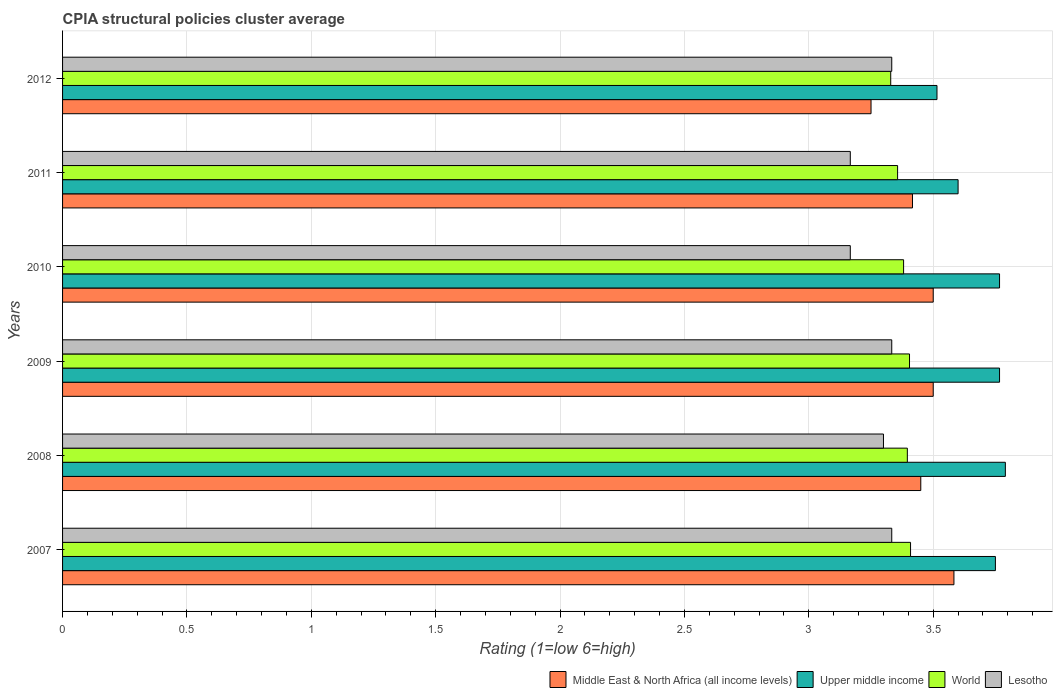Are the number of bars per tick equal to the number of legend labels?
Offer a terse response. Yes. Are the number of bars on each tick of the Y-axis equal?
Provide a short and direct response. Yes. How many bars are there on the 5th tick from the top?
Give a very brief answer. 4. What is the CPIA rating in Upper middle income in 2007?
Your response must be concise. 3.75. Across all years, what is the maximum CPIA rating in World?
Your answer should be compact. 3.41. Across all years, what is the minimum CPIA rating in Middle East & North Africa (all income levels)?
Keep it short and to the point. 3.25. What is the total CPIA rating in Lesotho in the graph?
Make the answer very short. 19.63. What is the difference between the CPIA rating in Middle East & North Africa (all income levels) in 2008 and that in 2012?
Provide a short and direct response. 0.2. What is the difference between the CPIA rating in Middle East & North Africa (all income levels) in 2009 and the CPIA rating in World in 2012?
Offer a very short reply. 0.17. What is the average CPIA rating in Lesotho per year?
Make the answer very short. 3.27. In the year 2011, what is the difference between the CPIA rating in Upper middle income and CPIA rating in World?
Provide a succinct answer. 0.24. In how many years, is the CPIA rating in Middle East & North Africa (all income levels) greater than 2.1 ?
Give a very brief answer. 6. What is the ratio of the CPIA rating in World in 2009 to that in 2012?
Your response must be concise. 1.02. What is the difference between the highest and the second highest CPIA rating in Upper middle income?
Give a very brief answer. 0.02. What is the difference between the highest and the lowest CPIA rating in World?
Provide a succinct answer. 0.08. In how many years, is the CPIA rating in World greater than the average CPIA rating in World taken over all years?
Your answer should be compact. 4. Is the sum of the CPIA rating in Middle East & North Africa (all income levels) in 2011 and 2012 greater than the maximum CPIA rating in World across all years?
Ensure brevity in your answer.  Yes. Is it the case that in every year, the sum of the CPIA rating in World and CPIA rating in Middle East & North Africa (all income levels) is greater than the sum of CPIA rating in Lesotho and CPIA rating in Upper middle income?
Provide a succinct answer. No. What does the 4th bar from the top in 2011 represents?
Your answer should be very brief. Middle East & North Africa (all income levels). What does the 4th bar from the bottom in 2012 represents?
Provide a succinct answer. Lesotho. Is it the case that in every year, the sum of the CPIA rating in World and CPIA rating in Upper middle income is greater than the CPIA rating in Middle East & North Africa (all income levels)?
Keep it short and to the point. Yes. How many bars are there?
Your answer should be very brief. 24. How many years are there in the graph?
Provide a short and direct response. 6. What is the difference between two consecutive major ticks on the X-axis?
Ensure brevity in your answer.  0.5. Are the values on the major ticks of X-axis written in scientific E-notation?
Your answer should be compact. No. Does the graph contain any zero values?
Offer a terse response. No. Does the graph contain grids?
Provide a short and direct response. Yes. How many legend labels are there?
Make the answer very short. 4. How are the legend labels stacked?
Provide a short and direct response. Horizontal. What is the title of the graph?
Offer a terse response. CPIA structural policies cluster average. What is the label or title of the X-axis?
Make the answer very short. Rating (1=low 6=high). What is the label or title of the Y-axis?
Your answer should be very brief. Years. What is the Rating (1=low 6=high) of Middle East & North Africa (all income levels) in 2007?
Offer a terse response. 3.58. What is the Rating (1=low 6=high) in Upper middle income in 2007?
Ensure brevity in your answer.  3.75. What is the Rating (1=low 6=high) in World in 2007?
Keep it short and to the point. 3.41. What is the Rating (1=low 6=high) of Lesotho in 2007?
Your answer should be very brief. 3.33. What is the Rating (1=low 6=high) of Middle East & North Africa (all income levels) in 2008?
Keep it short and to the point. 3.45. What is the Rating (1=low 6=high) in Upper middle income in 2008?
Provide a succinct answer. 3.79. What is the Rating (1=low 6=high) in World in 2008?
Offer a very short reply. 3.4. What is the Rating (1=low 6=high) of Lesotho in 2008?
Make the answer very short. 3.3. What is the Rating (1=low 6=high) in Upper middle income in 2009?
Provide a short and direct response. 3.77. What is the Rating (1=low 6=high) of World in 2009?
Your answer should be very brief. 3.4. What is the Rating (1=low 6=high) in Lesotho in 2009?
Give a very brief answer. 3.33. What is the Rating (1=low 6=high) in Middle East & North Africa (all income levels) in 2010?
Your response must be concise. 3.5. What is the Rating (1=low 6=high) of Upper middle income in 2010?
Offer a terse response. 3.77. What is the Rating (1=low 6=high) in World in 2010?
Your answer should be compact. 3.38. What is the Rating (1=low 6=high) in Lesotho in 2010?
Offer a very short reply. 3.17. What is the Rating (1=low 6=high) of Middle East & North Africa (all income levels) in 2011?
Your answer should be very brief. 3.42. What is the Rating (1=low 6=high) in Upper middle income in 2011?
Make the answer very short. 3.6. What is the Rating (1=low 6=high) in World in 2011?
Your answer should be very brief. 3.36. What is the Rating (1=low 6=high) in Lesotho in 2011?
Make the answer very short. 3.17. What is the Rating (1=low 6=high) in Upper middle income in 2012?
Your answer should be compact. 3.52. What is the Rating (1=low 6=high) in World in 2012?
Make the answer very short. 3.33. What is the Rating (1=low 6=high) in Lesotho in 2012?
Keep it short and to the point. 3.33. Across all years, what is the maximum Rating (1=low 6=high) of Middle East & North Africa (all income levels)?
Give a very brief answer. 3.58. Across all years, what is the maximum Rating (1=low 6=high) of Upper middle income?
Keep it short and to the point. 3.79. Across all years, what is the maximum Rating (1=low 6=high) of World?
Ensure brevity in your answer.  3.41. Across all years, what is the maximum Rating (1=low 6=high) of Lesotho?
Provide a succinct answer. 3.33. Across all years, what is the minimum Rating (1=low 6=high) of Middle East & North Africa (all income levels)?
Provide a short and direct response. 3.25. Across all years, what is the minimum Rating (1=low 6=high) of Upper middle income?
Offer a very short reply. 3.52. Across all years, what is the minimum Rating (1=low 6=high) in World?
Make the answer very short. 3.33. Across all years, what is the minimum Rating (1=low 6=high) in Lesotho?
Offer a terse response. 3.17. What is the total Rating (1=low 6=high) of Middle East & North Africa (all income levels) in the graph?
Your response must be concise. 20.7. What is the total Rating (1=low 6=high) of Upper middle income in the graph?
Provide a short and direct response. 22.19. What is the total Rating (1=low 6=high) in World in the graph?
Keep it short and to the point. 20.28. What is the total Rating (1=low 6=high) in Lesotho in the graph?
Your answer should be compact. 19.63. What is the difference between the Rating (1=low 6=high) in Middle East & North Africa (all income levels) in 2007 and that in 2008?
Offer a terse response. 0.13. What is the difference between the Rating (1=low 6=high) in Upper middle income in 2007 and that in 2008?
Make the answer very short. -0.04. What is the difference between the Rating (1=low 6=high) in World in 2007 and that in 2008?
Offer a very short reply. 0.01. What is the difference between the Rating (1=low 6=high) in Lesotho in 2007 and that in 2008?
Your response must be concise. 0.03. What is the difference between the Rating (1=low 6=high) in Middle East & North Africa (all income levels) in 2007 and that in 2009?
Make the answer very short. 0.08. What is the difference between the Rating (1=low 6=high) of Upper middle income in 2007 and that in 2009?
Ensure brevity in your answer.  -0.02. What is the difference between the Rating (1=low 6=high) of World in 2007 and that in 2009?
Your response must be concise. 0. What is the difference between the Rating (1=low 6=high) in Middle East & North Africa (all income levels) in 2007 and that in 2010?
Ensure brevity in your answer.  0.08. What is the difference between the Rating (1=low 6=high) of Upper middle income in 2007 and that in 2010?
Provide a short and direct response. -0.02. What is the difference between the Rating (1=low 6=high) in World in 2007 and that in 2010?
Provide a short and direct response. 0.03. What is the difference between the Rating (1=low 6=high) in Lesotho in 2007 and that in 2010?
Offer a very short reply. 0.17. What is the difference between the Rating (1=low 6=high) of Upper middle income in 2007 and that in 2011?
Ensure brevity in your answer.  0.15. What is the difference between the Rating (1=low 6=high) of World in 2007 and that in 2011?
Your answer should be compact. 0.05. What is the difference between the Rating (1=low 6=high) of Upper middle income in 2007 and that in 2012?
Make the answer very short. 0.23. What is the difference between the Rating (1=low 6=high) in World in 2007 and that in 2012?
Make the answer very short. 0.08. What is the difference between the Rating (1=low 6=high) of Upper middle income in 2008 and that in 2009?
Your response must be concise. 0.02. What is the difference between the Rating (1=low 6=high) of World in 2008 and that in 2009?
Give a very brief answer. -0.01. What is the difference between the Rating (1=low 6=high) of Lesotho in 2008 and that in 2009?
Offer a terse response. -0.03. What is the difference between the Rating (1=low 6=high) in Middle East & North Africa (all income levels) in 2008 and that in 2010?
Give a very brief answer. -0.05. What is the difference between the Rating (1=low 6=high) in Upper middle income in 2008 and that in 2010?
Make the answer very short. 0.02. What is the difference between the Rating (1=low 6=high) of World in 2008 and that in 2010?
Keep it short and to the point. 0.01. What is the difference between the Rating (1=low 6=high) in Lesotho in 2008 and that in 2010?
Your response must be concise. 0.13. What is the difference between the Rating (1=low 6=high) in Middle East & North Africa (all income levels) in 2008 and that in 2011?
Your answer should be compact. 0.03. What is the difference between the Rating (1=low 6=high) of Upper middle income in 2008 and that in 2011?
Provide a succinct answer. 0.19. What is the difference between the Rating (1=low 6=high) of World in 2008 and that in 2011?
Keep it short and to the point. 0.04. What is the difference between the Rating (1=low 6=high) of Lesotho in 2008 and that in 2011?
Provide a succinct answer. 0.13. What is the difference between the Rating (1=low 6=high) in Middle East & North Africa (all income levels) in 2008 and that in 2012?
Provide a succinct answer. 0.2. What is the difference between the Rating (1=low 6=high) in Upper middle income in 2008 and that in 2012?
Keep it short and to the point. 0.27. What is the difference between the Rating (1=low 6=high) in World in 2008 and that in 2012?
Make the answer very short. 0.07. What is the difference between the Rating (1=low 6=high) of Lesotho in 2008 and that in 2012?
Ensure brevity in your answer.  -0.03. What is the difference between the Rating (1=low 6=high) of Middle East & North Africa (all income levels) in 2009 and that in 2010?
Your answer should be compact. 0. What is the difference between the Rating (1=low 6=high) of World in 2009 and that in 2010?
Keep it short and to the point. 0.02. What is the difference between the Rating (1=low 6=high) of Lesotho in 2009 and that in 2010?
Your answer should be compact. 0.17. What is the difference between the Rating (1=low 6=high) of Middle East & North Africa (all income levels) in 2009 and that in 2011?
Your response must be concise. 0.08. What is the difference between the Rating (1=low 6=high) in Upper middle income in 2009 and that in 2011?
Give a very brief answer. 0.17. What is the difference between the Rating (1=low 6=high) in World in 2009 and that in 2011?
Provide a short and direct response. 0.05. What is the difference between the Rating (1=low 6=high) in Lesotho in 2009 and that in 2011?
Keep it short and to the point. 0.17. What is the difference between the Rating (1=low 6=high) of Middle East & North Africa (all income levels) in 2009 and that in 2012?
Your response must be concise. 0.25. What is the difference between the Rating (1=low 6=high) in Upper middle income in 2009 and that in 2012?
Offer a very short reply. 0.25. What is the difference between the Rating (1=low 6=high) of World in 2009 and that in 2012?
Your answer should be very brief. 0.08. What is the difference between the Rating (1=low 6=high) in Lesotho in 2009 and that in 2012?
Provide a short and direct response. 0. What is the difference between the Rating (1=low 6=high) of Middle East & North Africa (all income levels) in 2010 and that in 2011?
Ensure brevity in your answer.  0.08. What is the difference between the Rating (1=low 6=high) of World in 2010 and that in 2011?
Provide a succinct answer. 0.02. What is the difference between the Rating (1=low 6=high) in Lesotho in 2010 and that in 2011?
Your answer should be very brief. 0. What is the difference between the Rating (1=low 6=high) of Middle East & North Africa (all income levels) in 2010 and that in 2012?
Your response must be concise. 0.25. What is the difference between the Rating (1=low 6=high) of Upper middle income in 2010 and that in 2012?
Provide a short and direct response. 0.25. What is the difference between the Rating (1=low 6=high) of World in 2010 and that in 2012?
Ensure brevity in your answer.  0.05. What is the difference between the Rating (1=low 6=high) of Lesotho in 2010 and that in 2012?
Offer a very short reply. -0.17. What is the difference between the Rating (1=low 6=high) in Middle East & North Africa (all income levels) in 2011 and that in 2012?
Provide a short and direct response. 0.17. What is the difference between the Rating (1=low 6=high) in Upper middle income in 2011 and that in 2012?
Your answer should be very brief. 0.08. What is the difference between the Rating (1=low 6=high) of World in 2011 and that in 2012?
Keep it short and to the point. 0.03. What is the difference between the Rating (1=low 6=high) of Lesotho in 2011 and that in 2012?
Your response must be concise. -0.17. What is the difference between the Rating (1=low 6=high) in Middle East & North Africa (all income levels) in 2007 and the Rating (1=low 6=high) in Upper middle income in 2008?
Make the answer very short. -0.21. What is the difference between the Rating (1=low 6=high) of Middle East & North Africa (all income levels) in 2007 and the Rating (1=low 6=high) of World in 2008?
Keep it short and to the point. 0.19. What is the difference between the Rating (1=low 6=high) in Middle East & North Africa (all income levels) in 2007 and the Rating (1=low 6=high) in Lesotho in 2008?
Your answer should be compact. 0.28. What is the difference between the Rating (1=low 6=high) of Upper middle income in 2007 and the Rating (1=low 6=high) of World in 2008?
Your answer should be compact. 0.35. What is the difference between the Rating (1=low 6=high) of Upper middle income in 2007 and the Rating (1=low 6=high) of Lesotho in 2008?
Offer a terse response. 0.45. What is the difference between the Rating (1=low 6=high) of World in 2007 and the Rating (1=low 6=high) of Lesotho in 2008?
Your answer should be very brief. 0.11. What is the difference between the Rating (1=low 6=high) of Middle East & North Africa (all income levels) in 2007 and the Rating (1=low 6=high) of Upper middle income in 2009?
Ensure brevity in your answer.  -0.18. What is the difference between the Rating (1=low 6=high) of Middle East & North Africa (all income levels) in 2007 and the Rating (1=low 6=high) of World in 2009?
Keep it short and to the point. 0.18. What is the difference between the Rating (1=low 6=high) of Upper middle income in 2007 and the Rating (1=low 6=high) of World in 2009?
Ensure brevity in your answer.  0.35. What is the difference between the Rating (1=low 6=high) of Upper middle income in 2007 and the Rating (1=low 6=high) of Lesotho in 2009?
Your answer should be compact. 0.42. What is the difference between the Rating (1=low 6=high) in World in 2007 and the Rating (1=low 6=high) in Lesotho in 2009?
Provide a succinct answer. 0.08. What is the difference between the Rating (1=low 6=high) in Middle East & North Africa (all income levels) in 2007 and the Rating (1=low 6=high) in Upper middle income in 2010?
Provide a short and direct response. -0.18. What is the difference between the Rating (1=low 6=high) in Middle East & North Africa (all income levels) in 2007 and the Rating (1=low 6=high) in World in 2010?
Provide a short and direct response. 0.2. What is the difference between the Rating (1=low 6=high) in Middle East & North Africa (all income levels) in 2007 and the Rating (1=low 6=high) in Lesotho in 2010?
Provide a succinct answer. 0.42. What is the difference between the Rating (1=low 6=high) of Upper middle income in 2007 and the Rating (1=low 6=high) of World in 2010?
Provide a short and direct response. 0.37. What is the difference between the Rating (1=low 6=high) in Upper middle income in 2007 and the Rating (1=low 6=high) in Lesotho in 2010?
Your answer should be compact. 0.58. What is the difference between the Rating (1=low 6=high) in World in 2007 and the Rating (1=low 6=high) in Lesotho in 2010?
Provide a short and direct response. 0.24. What is the difference between the Rating (1=low 6=high) of Middle East & North Africa (all income levels) in 2007 and the Rating (1=low 6=high) of Upper middle income in 2011?
Your response must be concise. -0.02. What is the difference between the Rating (1=low 6=high) in Middle East & North Africa (all income levels) in 2007 and the Rating (1=low 6=high) in World in 2011?
Your answer should be compact. 0.23. What is the difference between the Rating (1=low 6=high) in Middle East & North Africa (all income levels) in 2007 and the Rating (1=low 6=high) in Lesotho in 2011?
Your answer should be very brief. 0.42. What is the difference between the Rating (1=low 6=high) of Upper middle income in 2007 and the Rating (1=low 6=high) of World in 2011?
Keep it short and to the point. 0.39. What is the difference between the Rating (1=low 6=high) of Upper middle income in 2007 and the Rating (1=low 6=high) of Lesotho in 2011?
Ensure brevity in your answer.  0.58. What is the difference between the Rating (1=low 6=high) in World in 2007 and the Rating (1=low 6=high) in Lesotho in 2011?
Your response must be concise. 0.24. What is the difference between the Rating (1=low 6=high) of Middle East & North Africa (all income levels) in 2007 and the Rating (1=low 6=high) of Upper middle income in 2012?
Keep it short and to the point. 0.07. What is the difference between the Rating (1=low 6=high) of Middle East & North Africa (all income levels) in 2007 and the Rating (1=low 6=high) of World in 2012?
Your response must be concise. 0.25. What is the difference between the Rating (1=low 6=high) in Middle East & North Africa (all income levels) in 2007 and the Rating (1=low 6=high) in Lesotho in 2012?
Make the answer very short. 0.25. What is the difference between the Rating (1=low 6=high) of Upper middle income in 2007 and the Rating (1=low 6=high) of World in 2012?
Make the answer very short. 0.42. What is the difference between the Rating (1=low 6=high) in Upper middle income in 2007 and the Rating (1=low 6=high) in Lesotho in 2012?
Offer a terse response. 0.42. What is the difference between the Rating (1=low 6=high) in World in 2007 and the Rating (1=low 6=high) in Lesotho in 2012?
Your response must be concise. 0.08. What is the difference between the Rating (1=low 6=high) in Middle East & North Africa (all income levels) in 2008 and the Rating (1=low 6=high) in Upper middle income in 2009?
Offer a very short reply. -0.32. What is the difference between the Rating (1=low 6=high) in Middle East & North Africa (all income levels) in 2008 and the Rating (1=low 6=high) in World in 2009?
Your response must be concise. 0.05. What is the difference between the Rating (1=low 6=high) in Middle East & North Africa (all income levels) in 2008 and the Rating (1=low 6=high) in Lesotho in 2009?
Offer a terse response. 0.12. What is the difference between the Rating (1=low 6=high) of Upper middle income in 2008 and the Rating (1=low 6=high) of World in 2009?
Your answer should be compact. 0.39. What is the difference between the Rating (1=low 6=high) in Upper middle income in 2008 and the Rating (1=low 6=high) in Lesotho in 2009?
Give a very brief answer. 0.46. What is the difference between the Rating (1=low 6=high) in World in 2008 and the Rating (1=low 6=high) in Lesotho in 2009?
Your response must be concise. 0.06. What is the difference between the Rating (1=low 6=high) in Middle East & North Africa (all income levels) in 2008 and the Rating (1=low 6=high) in Upper middle income in 2010?
Offer a very short reply. -0.32. What is the difference between the Rating (1=low 6=high) of Middle East & North Africa (all income levels) in 2008 and the Rating (1=low 6=high) of World in 2010?
Offer a very short reply. 0.07. What is the difference between the Rating (1=low 6=high) of Middle East & North Africa (all income levels) in 2008 and the Rating (1=low 6=high) of Lesotho in 2010?
Make the answer very short. 0.28. What is the difference between the Rating (1=low 6=high) in Upper middle income in 2008 and the Rating (1=low 6=high) in World in 2010?
Your answer should be compact. 0.41. What is the difference between the Rating (1=low 6=high) of Upper middle income in 2008 and the Rating (1=low 6=high) of Lesotho in 2010?
Provide a short and direct response. 0.62. What is the difference between the Rating (1=low 6=high) of World in 2008 and the Rating (1=low 6=high) of Lesotho in 2010?
Your answer should be compact. 0.23. What is the difference between the Rating (1=low 6=high) of Middle East & North Africa (all income levels) in 2008 and the Rating (1=low 6=high) of Upper middle income in 2011?
Keep it short and to the point. -0.15. What is the difference between the Rating (1=low 6=high) in Middle East & North Africa (all income levels) in 2008 and the Rating (1=low 6=high) in World in 2011?
Your answer should be compact. 0.09. What is the difference between the Rating (1=low 6=high) in Middle East & North Africa (all income levels) in 2008 and the Rating (1=low 6=high) in Lesotho in 2011?
Your response must be concise. 0.28. What is the difference between the Rating (1=low 6=high) in Upper middle income in 2008 and the Rating (1=low 6=high) in World in 2011?
Offer a very short reply. 0.43. What is the difference between the Rating (1=low 6=high) in Upper middle income in 2008 and the Rating (1=low 6=high) in Lesotho in 2011?
Keep it short and to the point. 0.62. What is the difference between the Rating (1=low 6=high) of World in 2008 and the Rating (1=low 6=high) of Lesotho in 2011?
Keep it short and to the point. 0.23. What is the difference between the Rating (1=low 6=high) in Middle East & North Africa (all income levels) in 2008 and the Rating (1=low 6=high) in Upper middle income in 2012?
Offer a very short reply. -0.07. What is the difference between the Rating (1=low 6=high) of Middle East & North Africa (all income levels) in 2008 and the Rating (1=low 6=high) of World in 2012?
Ensure brevity in your answer.  0.12. What is the difference between the Rating (1=low 6=high) in Middle East & North Africa (all income levels) in 2008 and the Rating (1=low 6=high) in Lesotho in 2012?
Ensure brevity in your answer.  0.12. What is the difference between the Rating (1=low 6=high) in Upper middle income in 2008 and the Rating (1=low 6=high) in World in 2012?
Offer a terse response. 0.46. What is the difference between the Rating (1=low 6=high) of Upper middle income in 2008 and the Rating (1=low 6=high) of Lesotho in 2012?
Provide a short and direct response. 0.46. What is the difference between the Rating (1=low 6=high) of World in 2008 and the Rating (1=low 6=high) of Lesotho in 2012?
Your answer should be very brief. 0.06. What is the difference between the Rating (1=low 6=high) in Middle East & North Africa (all income levels) in 2009 and the Rating (1=low 6=high) in Upper middle income in 2010?
Make the answer very short. -0.27. What is the difference between the Rating (1=low 6=high) of Middle East & North Africa (all income levels) in 2009 and the Rating (1=low 6=high) of World in 2010?
Keep it short and to the point. 0.12. What is the difference between the Rating (1=low 6=high) in Upper middle income in 2009 and the Rating (1=low 6=high) in World in 2010?
Make the answer very short. 0.39. What is the difference between the Rating (1=low 6=high) in World in 2009 and the Rating (1=low 6=high) in Lesotho in 2010?
Ensure brevity in your answer.  0.24. What is the difference between the Rating (1=low 6=high) of Middle East & North Africa (all income levels) in 2009 and the Rating (1=low 6=high) of Upper middle income in 2011?
Ensure brevity in your answer.  -0.1. What is the difference between the Rating (1=low 6=high) in Middle East & North Africa (all income levels) in 2009 and the Rating (1=low 6=high) in World in 2011?
Give a very brief answer. 0.14. What is the difference between the Rating (1=low 6=high) of Upper middle income in 2009 and the Rating (1=low 6=high) of World in 2011?
Ensure brevity in your answer.  0.41. What is the difference between the Rating (1=low 6=high) in Upper middle income in 2009 and the Rating (1=low 6=high) in Lesotho in 2011?
Your response must be concise. 0.6. What is the difference between the Rating (1=low 6=high) in World in 2009 and the Rating (1=low 6=high) in Lesotho in 2011?
Offer a very short reply. 0.24. What is the difference between the Rating (1=low 6=high) of Middle East & North Africa (all income levels) in 2009 and the Rating (1=low 6=high) of Upper middle income in 2012?
Your response must be concise. -0.02. What is the difference between the Rating (1=low 6=high) in Middle East & North Africa (all income levels) in 2009 and the Rating (1=low 6=high) in World in 2012?
Give a very brief answer. 0.17. What is the difference between the Rating (1=low 6=high) in Middle East & North Africa (all income levels) in 2009 and the Rating (1=low 6=high) in Lesotho in 2012?
Keep it short and to the point. 0.17. What is the difference between the Rating (1=low 6=high) in Upper middle income in 2009 and the Rating (1=low 6=high) in World in 2012?
Provide a succinct answer. 0.44. What is the difference between the Rating (1=low 6=high) of Upper middle income in 2009 and the Rating (1=low 6=high) of Lesotho in 2012?
Your answer should be compact. 0.43. What is the difference between the Rating (1=low 6=high) in World in 2009 and the Rating (1=low 6=high) in Lesotho in 2012?
Your answer should be compact. 0.07. What is the difference between the Rating (1=low 6=high) of Middle East & North Africa (all income levels) in 2010 and the Rating (1=low 6=high) of Upper middle income in 2011?
Provide a succinct answer. -0.1. What is the difference between the Rating (1=low 6=high) of Middle East & North Africa (all income levels) in 2010 and the Rating (1=low 6=high) of World in 2011?
Your response must be concise. 0.14. What is the difference between the Rating (1=low 6=high) in Upper middle income in 2010 and the Rating (1=low 6=high) in World in 2011?
Offer a terse response. 0.41. What is the difference between the Rating (1=low 6=high) of Upper middle income in 2010 and the Rating (1=low 6=high) of Lesotho in 2011?
Offer a very short reply. 0.6. What is the difference between the Rating (1=low 6=high) of World in 2010 and the Rating (1=low 6=high) of Lesotho in 2011?
Give a very brief answer. 0.21. What is the difference between the Rating (1=low 6=high) in Middle East & North Africa (all income levels) in 2010 and the Rating (1=low 6=high) in Upper middle income in 2012?
Keep it short and to the point. -0.02. What is the difference between the Rating (1=low 6=high) of Middle East & North Africa (all income levels) in 2010 and the Rating (1=low 6=high) of World in 2012?
Your answer should be compact. 0.17. What is the difference between the Rating (1=low 6=high) of Upper middle income in 2010 and the Rating (1=low 6=high) of World in 2012?
Offer a terse response. 0.44. What is the difference between the Rating (1=low 6=high) of Upper middle income in 2010 and the Rating (1=low 6=high) of Lesotho in 2012?
Provide a succinct answer. 0.43. What is the difference between the Rating (1=low 6=high) in World in 2010 and the Rating (1=low 6=high) in Lesotho in 2012?
Offer a very short reply. 0.05. What is the difference between the Rating (1=low 6=high) of Middle East & North Africa (all income levels) in 2011 and the Rating (1=low 6=high) of Upper middle income in 2012?
Make the answer very short. -0.1. What is the difference between the Rating (1=low 6=high) of Middle East & North Africa (all income levels) in 2011 and the Rating (1=low 6=high) of World in 2012?
Offer a terse response. 0.09. What is the difference between the Rating (1=low 6=high) of Middle East & North Africa (all income levels) in 2011 and the Rating (1=low 6=high) of Lesotho in 2012?
Ensure brevity in your answer.  0.08. What is the difference between the Rating (1=low 6=high) of Upper middle income in 2011 and the Rating (1=low 6=high) of World in 2012?
Your response must be concise. 0.27. What is the difference between the Rating (1=low 6=high) of Upper middle income in 2011 and the Rating (1=low 6=high) of Lesotho in 2012?
Ensure brevity in your answer.  0.27. What is the difference between the Rating (1=low 6=high) of World in 2011 and the Rating (1=low 6=high) of Lesotho in 2012?
Offer a very short reply. 0.02. What is the average Rating (1=low 6=high) of Middle East & North Africa (all income levels) per year?
Keep it short and to the point. 3.45. What is the average Rating (1=low 6=high) in Upper middle income per year?
Ensure brevity in your answer.  3.7. What is the average Rating (1=low 6=high) in World per year?
Provide a short and direct response. 3.38. What is the average Rating (1=low 6=high) in Lesotho per year?
Ensure brevity in your answer.  3.27. In the year 2007, what is the difference between the Rating (1=low 6=high) of Middle East & North Africa (all income levels) and Rating (1=low 6=high) of Upper middle income?
Offer a terse response. -0.17. In the year 2007, what is the difference between the Rating (1=low 6=high) of Middle East & North Africa (all income levels) and Rating (1=low 6=high) of World?
Ensure brevity in your answer.  0.17. In the year 2007, what is the difference between the Rating (1=low 6=high) of Upper middle income and Rating (1=low 6=high) of World?
Keep it short and to the point. 0.34. In the year 2007, what is the difference between the Rating (1=low 6=high) of Upper middle income and Rating (1=low 6=high) of Lesotho?
Ensure brevity in your answer.  0.42. In the year 2007, what is the difference between the Rating (1=low 6=high) of World and Rating (1=low 6=high) of Lesotho?
Your answer should be very brief. 0.08. In the year 2008, what is the difference between the Rating (1=low 6=high) in Middle East & North Africa (all income levels) and Rating (1=low 6=high) in Upper middle income?
Your answer should be very brief. -0.34. In the year 2008, what is the difference between the Rating (1=low 6=high) of Middle East & North Africa (all income levels) and Rating (1=low 6=high) of World?
Ensure brevity in your answer.  0.05. In the year 2008, what is the difference between the Rating (1=low 6=high) of Middle East & North Africa (all income levels) and Rating (1=low 6=high) of Lesotho?
Provide a short and direct response. 0.15. In the year 2008, what is the difference between the Rating (1=low 6=high) in Upper middle income and Rating (1=low 6=high) in World?
Give a very brief answer. 0.39. In the year 2008, what is the difference between the Rating (1=low 6=high) in Upper middle income and Rating (1=low 6=high) in Lesotho?
Give a very brief answer. 0.49. In the year 2008, what is the difference between the Rating (1=low 6=high) in World and Rating (1=low 6=high) in Lesotho?
Give a very brief answer. 0.1. In the year 2009, what is the difference between the Rating (1=low 6=high) in Middle East & North Africa (all income levels) and Rating (1=low 6=high) in Upper middle income?
Provide a short and direct response. -0.27. In the year 2009, what is the difference between the Rating (1=low 6=high) of Middle East & North Africa (all income levels) and Rating (1=low 6=high) of World?
Your answer should be very brief. 0.1. In the year 2009, what is the difference between the Rating (1=low 6=high) in Middle East & North Africa (all income levels) and Rating (1=low 6=high) in Lesotho?
Your answer should be very brief. 0.17. In the year 2009, what is the difference between the Rating (1=low 6=high) of Upper middle income and Rating (1=low 6=high) of World?
Offer a terse response. 0.36. In the year 2009, what is the difference between the Rating (1=low 6=high) of Upper middle income and Rating (1=low 6=high) of Lesotho?
Ensure brevity in your answer.  0.43. In the year 2009, what is the difference between the Rating (1=low 6=high) of World and Rating (1=low 6=high) of Lesotho?
Your response must be concise. 0.07. In the year 2010, what is the difference between the Rating (1=low 6=high) in Middle East & North Africa (all income levels) and Rating (1=low 6=high) in Upper middle income?
Make the answer very short. -0.27. In the year 2010, what is the difference between the Rating (1=low 6=high) in Middle East & North Africa (all income levels) and Rating (1=low 6=high) in World?
Your answer should be very brief. 0.12. In the year 2010, what is the difference between the Rating (1=low 6=high) of Upper middle income and Rating (1=low 6=high) of World?
Offer a terse response. 0.39. In the year 2010, what is the difference between the Rating (1=low 6=high) of Upper middle income and Rating (1=low 6=high) of Lesotho?
Provide a short and direct response. 0.6. In the year 2010, what is the difference between the Rating (1=low 6=high) in World and Rating (1=low 6=high) in Lesotho?
Give a very brief answer. 0.21. In the year 2011, what is the difference between the Rating (1=low 6=high) in Middle East & North Africa (all income levels) and Rating (1=low 6=high) in Upper middle income?
Keep it short and to the point. -0.18. In the year 2011, what is the difference between the Rating (1=low 6=high) in Middle East & North Africa (all income levels) and Rating (1=low 6=high) in World?
Provide a succinct answer. 0.06. In the year 2011, what is the difference between the Rating (1=low 6=high) in Upper middle income and Rating (1=low 6=high) in World?
Your response must be concise. 0.24. In the year 2011, what is the difference between the Rating (1=low 6=high) of Upper middle income and Rating (1=low 6=high) of Lesotho?
Your answer should be very brief. 0.43. In the year 2011, what is the difference between the Rating (1=low 6=high) in World and Rating (1=low 6=high) in Lesotho?
Provide a succinct answer. 0.19. In the year 2012, what is the difference between the Rating (1=low 6=high) of Middle East & North Africa (all income levels) and Rating (1=low 6=high) of Upper middle income?
Your answer should be compact. -0.27. In the year 2012, what is the difference between the Rating (1=low 6=high) in Middle East & North Africa (all income levels) and Rating (1=low 6=high) in World?
Provide a succinct answer. -0.08. In the year 2012, what is the difference between the Rating (1=low 6=high) in Middle East & North Africa (all income levels) and Rating (1=low 6=high) in Lesotho?
Give a very brief answer. -0.08. In the year 2012, what is the difference between the Rating (1=low 6=high) in Upper middle income and Rating (1=low 6=high) in World?
Give a very brief answer. 0.19. In the year 2012, what is the difference between the Rating (1=low 6=high) in Upper middle income and Rating (1=low 6=high) in Lesotho?
Give a very brief answer. 0.18. In the year 2012, what is the difference between the Rating (1=low 6=high) of World and Rating (1=low 6=high) of Lesotho?
Your response must be concise. -0. What is the ratio of the Rating (1=low 6=high) of Middle East & North Africa (all income levels) in 2007 to that in 2008?
Your answer should be compact. 1.04. What is the ratio of the Rating (1=low 6=high) of Upper middle income in 2007 to that in 2008?
Your answer should be very brief. 0.99. What is the ratio of the Rating (1=low 6=high) in Lesotho in 2007 to that in 2008?
Ensure brevity in your answer.  1.01. What is the ratio of the Rating (1=low 6=high) in Middle East & North Africa (all income levels) in 2007 to that in 2009?
Your answer should be very brief. 1.02. What is the ratio of the Rating (1=low 6=high) in Middle East & North Africa (all income levels) in 2007 to that in 2010?
Provide a short and direct response. 1.02. What is the ratio of the Rating (1=low 6=high) in Upper middle income in 2007 to that in 2010?
Your answer should be compact. 1. What is the ratio of the Rating (1=low 6=high) of World in 2007 to that in 2010?
Your answer should be compact. 1.01. What is the ratio of the Rating (1=low 6=high) in Lesotho in 2007 to that in 2010?
Offer a terse response. 1.05. What is the ratio of the Rating (1=low 6=high) in Middle East & North Africa (all income levels) in 2007 to that in 2011?
Your answer should be very brief. 1.05. What is the ratio of the Rating (1=low 6=high) of Upper middle income in 2007 to that in 2011?
Keep it short and to the point. 1.04. What is the ratio of the Rating (1=low 6=high) in World in 2007 to that in 2011?
Provide a short and direct response. 1.02. What is the ratio of the Rating (1=low 6=high) in Lesotho in 2007 to that in 2011?
Your answer should be compact. 1.05. What is the ratio of the Rating (1=low 6=high) in Middle East & North Africa (all income levels) in 2007 to that in 2012?
Make the answer very short. 1.1. What is the ratio of the Rating (1=low 6=high) of Upper middle income in 2007 to that in 2012?
Make the answer very short. 1.07. What is the ratio of the Rating (1=low 6=high) of World in 2007 to that in 2012?
Provide a succinct answer. 1.02. What is the ratio of the Rating (1=low 6=high) in Middle East & North Africa (all income levels) in 2008 to that in 2009?
Make the answer very short. 0.99. What is the ratio of the Rating (1=low 6=high) in Upper middle income in 2008 to that in 2009?
Your answer should be compact. 1.01. What is the ratio of the Rating (1=low 6=high) in Middle East & North Africa (all income levels) in 2008 to that in 2010?
Make the answer very short. 0.99. What is the ratio of the Rating (1=low 6=high) in Upper middle income in 2008 to that in 2010?
Provide a succinct answer. 1.01. What is the ratio of the Rating (1=low 6=high) of World in 2008 to that in 2010?
Ensure brevity in your answer.  1. What is the ratio of the Rating (1=low 6=high) of Lesotho in 2008 to that in 2010?
Provide a succinct answer. 1.04. What is the ratio of the Rating (1=low 6=high) of Middle East & North Africa (all income levels) in 2008 to that in 2011?
Offer a terse response. 1.01. What is the ratio of the Rating (1=low 6=high) in Upper middle income in 2008 to that in 2011?
Keep it short and to the point. 1.05. What is the ratio of the Rating (1=low 6=high) of World in 2008 to that in 2011?
Give a very brief answer. 1.01. What is the ratio of the Rating (1=low 6=high) in Lesotho in 2008 to that in 2011?
Ensure brevity in your answer.  1.04. What is the ratio of the Rating (1=low 6=high) of Middle East & North Africa (all income levels) in 2008 to that in 2012?
Your answer should be compact. 1.06. What is the ratio of the Rating (1=low 6=high) in Upper middle income in 2008 to that in 2012?
Your response must be concise. 1.08. What is the ratio of the Rating (1=low 6=high) of World in 2008 to that in 2012?
Ensure brevity in your answer.  1.02. What is the ratio of the Rating (1=low 6=high) of Middle East & North Africa (all income levels) in 2009 to that in 2010?
Your response must be concise. 1. What is the ratio of the Rating (1=low 6=high) in Lesotho in 2009 to that in 2010?
Offer a terse response. 1.05. What is the ratio of the Rating (1=low 6=high) in Middle East & North Africa (all income levels) in 2009 to that in 2011?
Make the answer very short. 1.02. What is the ratio of the Rating (1=low 6=high) in Upper middle income in 2009 to that in 2011?
Make the answer very short. 1.05. What is the ratio of the Rating (1=low 6=high) of World in 2009 to that in 2011?
Provide a succinct answer. 1.01. What is the ratio of the Rating (1=low 6=high) of Lesotho in 2009 to that in 2011?
Provide a short and direct response. 1.05. What is the ratio of the Rating (1=low 6=high) of Upper middle income in 2009 to that in 2012?
Offer a very short reply. 1.07. What is the ratio of the Rating (1=low 6=high) in World in 2009 to that in 2012?
Provide a short and direct response. 1.02. What is the ratio of the Rating (1=low 6=high) in Lesotho in 2009 to that in 2012?
Make the answer very short. 1. What is the ratio of the Rating (1=low 6=high) in Middle East & North Africa (all income levels) in 2010 to that in 2011?
Offer a terse response. 1.02. What is the ratio of the Rating (1=low 6=high) of Upper middle income in 2010 to that in 2011?
Offer a terse response. 1.05. What is the ratio of the Rating (1=low 6=high) in World in 2010 to that in 2011?
Ensure brevity in your answer.  1.01. What is the ratio of the Rating (1=low 6=high) of Upper middle income in 2010 to that in 2012?
Your answer should be very brief. 1.07. What is the ratio of the Rating (1=low 6=high) of World in 2010 to that in 2012?
Provide a short and direct response. 1.02. What is the ratio of the Rating (1=low 6=high) of Lesotho in 2010 to that in 2012?
Your answer should be very brief. 0.95. What is the ratio of the Rating (1=low 6=high) in Middle East & North Africa (all income levels) in 2011 to that in 2012?
Give a very brief answer. 1.05. What is the ratio of the Rating (1=low 6=high) of Upper middle income in 2011 to that in 2012?
Offer a terse response. 1.02. What is the ratio of the Rating (1=low 6=high) of World in 2011 to that in 2012?
Give a very brief answer. 1.01. What is the difference between the highest and the second highest Rating (1=low 6=high) in Middle East & North Africa (all income levels)?
Provide a short and direct response. 0.08. What is the difference between the highest and the second highest Rating (1=low 6=high) in Upper middle income?
Your answer should be very brief. 0.02. What is the difference between the highest and the second highest Rating (1=low 6=high) of World?
Ensure brevity in your answer.  0. What is the difference between the highest and the second highest Rating (1=low 6=high) of Lesotho?
Your answer should be very brief. 0. What is the difference between the highest and the lowest Rating (1=low 6=high) of Middle East & North Africa (all income levels)?
Keep it short and to the point. 0.33. What is the difference between the highest and the lowest Rating (1=low 6=high) in Upper middle income?
Keep it short and to the point. 0.27. What is the difference between the highest and the lowest Rating (1=low 6=high) of World?
Offer a very short reply. 0.08. 